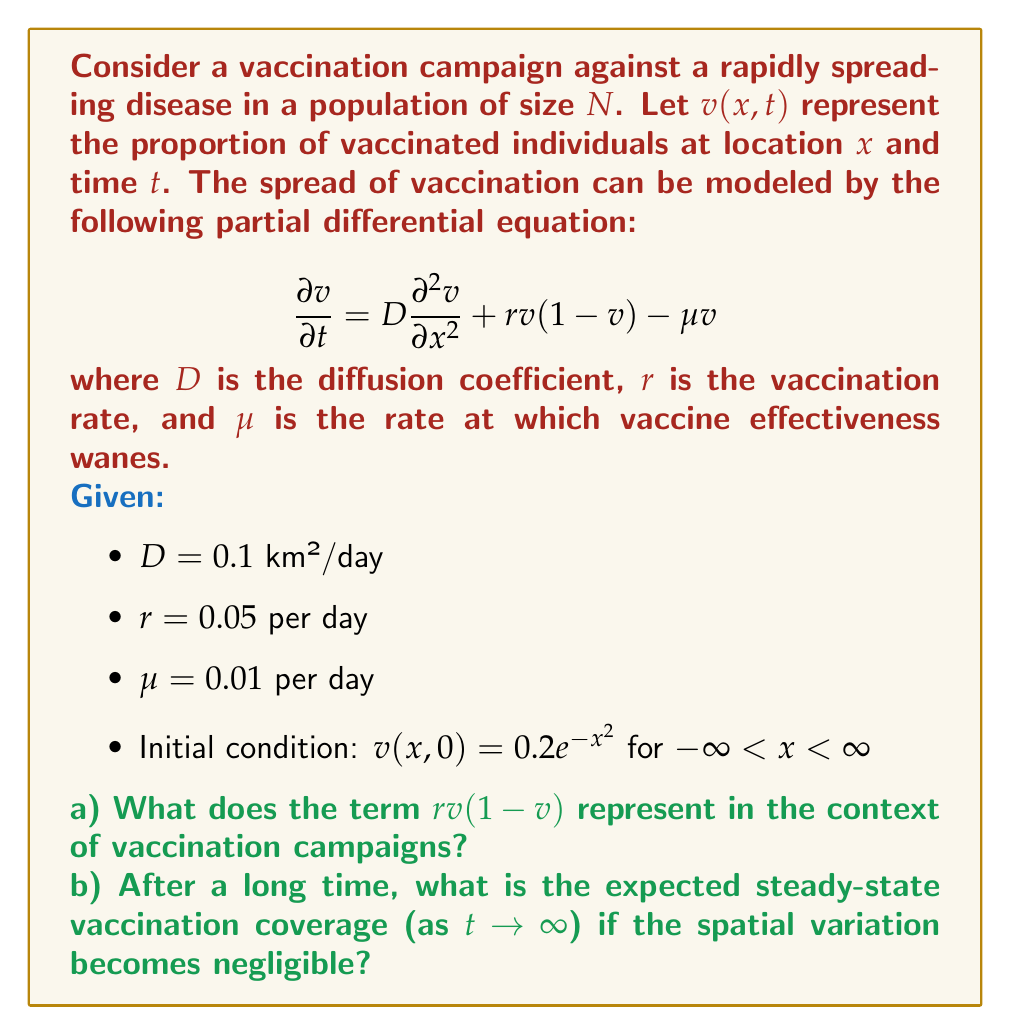Teach me how to tackle this problem. This question is tailored to a global health worker familiar with vaccination campaigns, utilizing a time-dependent PDE to model the spread of vaccination in a population.

a) The term $r v(1-v)$ represents the logistic growth of the vaccinated population. In the context of vaccination campaigns:
   - $r$ is the vaccination rate
   - $v$ is the proportion of vaccinated individuals
   - $(1-v)$ is the proportion of unvaccinated individuals

   This term captures the idea that as more people get vaccinated, it becomes harder to find unvaccinated individuals, slowing down the vaccination rate. This is a common challenge in vaccination campaigns, especially in the later stages.

b) To find the steady-state vaccination coverage, we need to solve for $v$ when $\frac{\partial v}{\partial t} = 0$ and spatial variation is negligible ($\frac{\partial^2 v}{\partial x^2} = 0$).

   Setting $\frac{\partial v}{\partial t} = 0$ in the original equation:

   $$0 = r v(1-v) - \mu v$$

   Factoring out $v$:

   $$0 = v(r(1-v) - \mu)$$

   This equation has two solutions: $v = 0$ or $r(1-v) - \mu = 0$

   Solving the second equation:

   $$r - rv - \mu = 0$$
   $$r - rv = \mu$$
   $$r - \mu = rv$$
   $$v = \frac{r - \mu}{r}$$

   Substituting the given values:

   $$v = \frac{0.05 - 0.01}{0.05} = \frac{0.04}{0.05} = 0.8$$

   The steady-state solution $v = 0$ is unstable, so the stable steady-state is $v = 0.8$.
Answer: a) The term $r v(1-v)$ represents the logistic growth of the vaccinated population, capturing the slowing vaccination rate as the proportion of vaccinated individuals increases.

b) The expected steady-state vaccination coverage as $t \to \infty$ is $v = 0.8$ or 80%. 